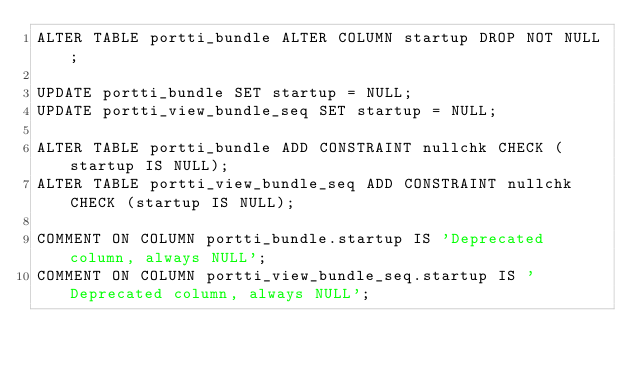Convert code to text. <code><loc_0><loc_0><loc_500><loc_500><_SQL_>ALTER TABLE portti_bundle ALTER COLUMN startup DROP NOT NULL;

UPDATE portti_bundle SET startup = NULL;
UPDATE portti_view_bundle_seq SET startup = NULL;

ALTER TABLE portti_bundle ADD CONSTRAINT nullchk CHECK (startup IS NULL);
ALTER TABLE portti_view_bundle_seq ADD CONSTRAINT nullchk CHECK (startup IS NULL);

COMMENT ON COLUMN portti_bundle.startup IS 'Deprecated column, always NULL';
COMMENT ON COLUMN portti_view_bundle_seq.startup IS 'Deprecated column, always NULL';</code> 